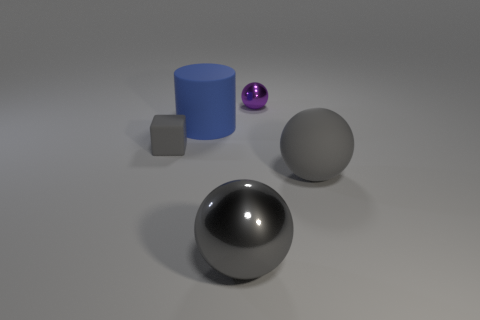There is a gray object to the right of the shiny sphere behind the large rubber thing that is behind the small gray thing; what is its size?
Offer a terse response. Large. There is another tiny object that is the same shape as the gray metallic thing; what color is it?
Your response must be concise. Purple. Does the blue rubber thing have the same size as the gray metallic object?
Provide a short and direct response. Yes. What is the ball behind the large rubber cylinder made of?
Keep it short and to the point. Metal. What number of other things are there of the same shape as the blue thing?
Keep it short and to the point. 0. Do the tiny rubber thing and the large gray rubber thing have the same shape?
Your response must be concise. No. Are there any small blocks behind the blue matte cylinder?
Ensure brevity in your answer.  No. How many things are big metallic spheres or small brown metal things?
Keep it short and to the point. 1. What number of other things are the same size as the gray matte cube?
Keep it short and to the point. 1. How many things are both on the left side of the blue cylinder and behind the blue matte cylinder?
Offer a very short reply. 0. 